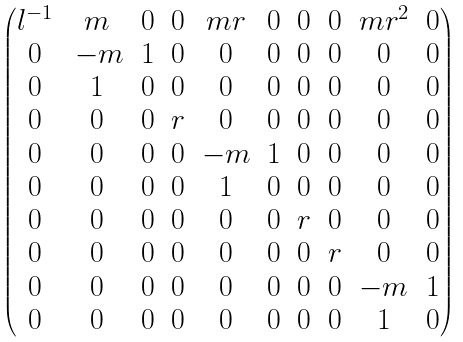Convert formula to latex. <formula><loc_0><loc_0><loc_500><loc_500>\begin{pmatrix} l ^ { - 1 } & m & 0 & 0 & m r & 0 & 0 & 0 & m r ^ { 2 } & 0 \\ 0 & \, - m & 1 & 0 & 0 & 0 & 0 & 0 & 0 & 0 \\ 0 & 1 & 0 & 0 & 0 & 0 & 0 & 0 & 0 & 0 \\ 0 & 0 & 0 & r & 0 & 0 & 0 & 0 & 0 & 0 \\ 0 & 0 & 0 & 0 & - m & 1 & 0 & 0 & 0 & 0 \\ 0 & 0 & 0 & 0 & 1 & 0 & 0 & 0 & 0 & 0 \\ 0 & 0 & 0 & 0 & 0 & 0 & r & 0 & 0 & 0 \\ 0 & 0 & 0 & 0 & 0 & 0 & 0 & r & 0 & 0 \\ 0 & 0 & 0 & 0 & 0 & 0 & 0 & 0 & - m & 1 \\ 0 & 0 & 0 & 0 & 0 & 0 & 0 & 0 & 1 & 0 \\ \end{pmatrix}</formula> 